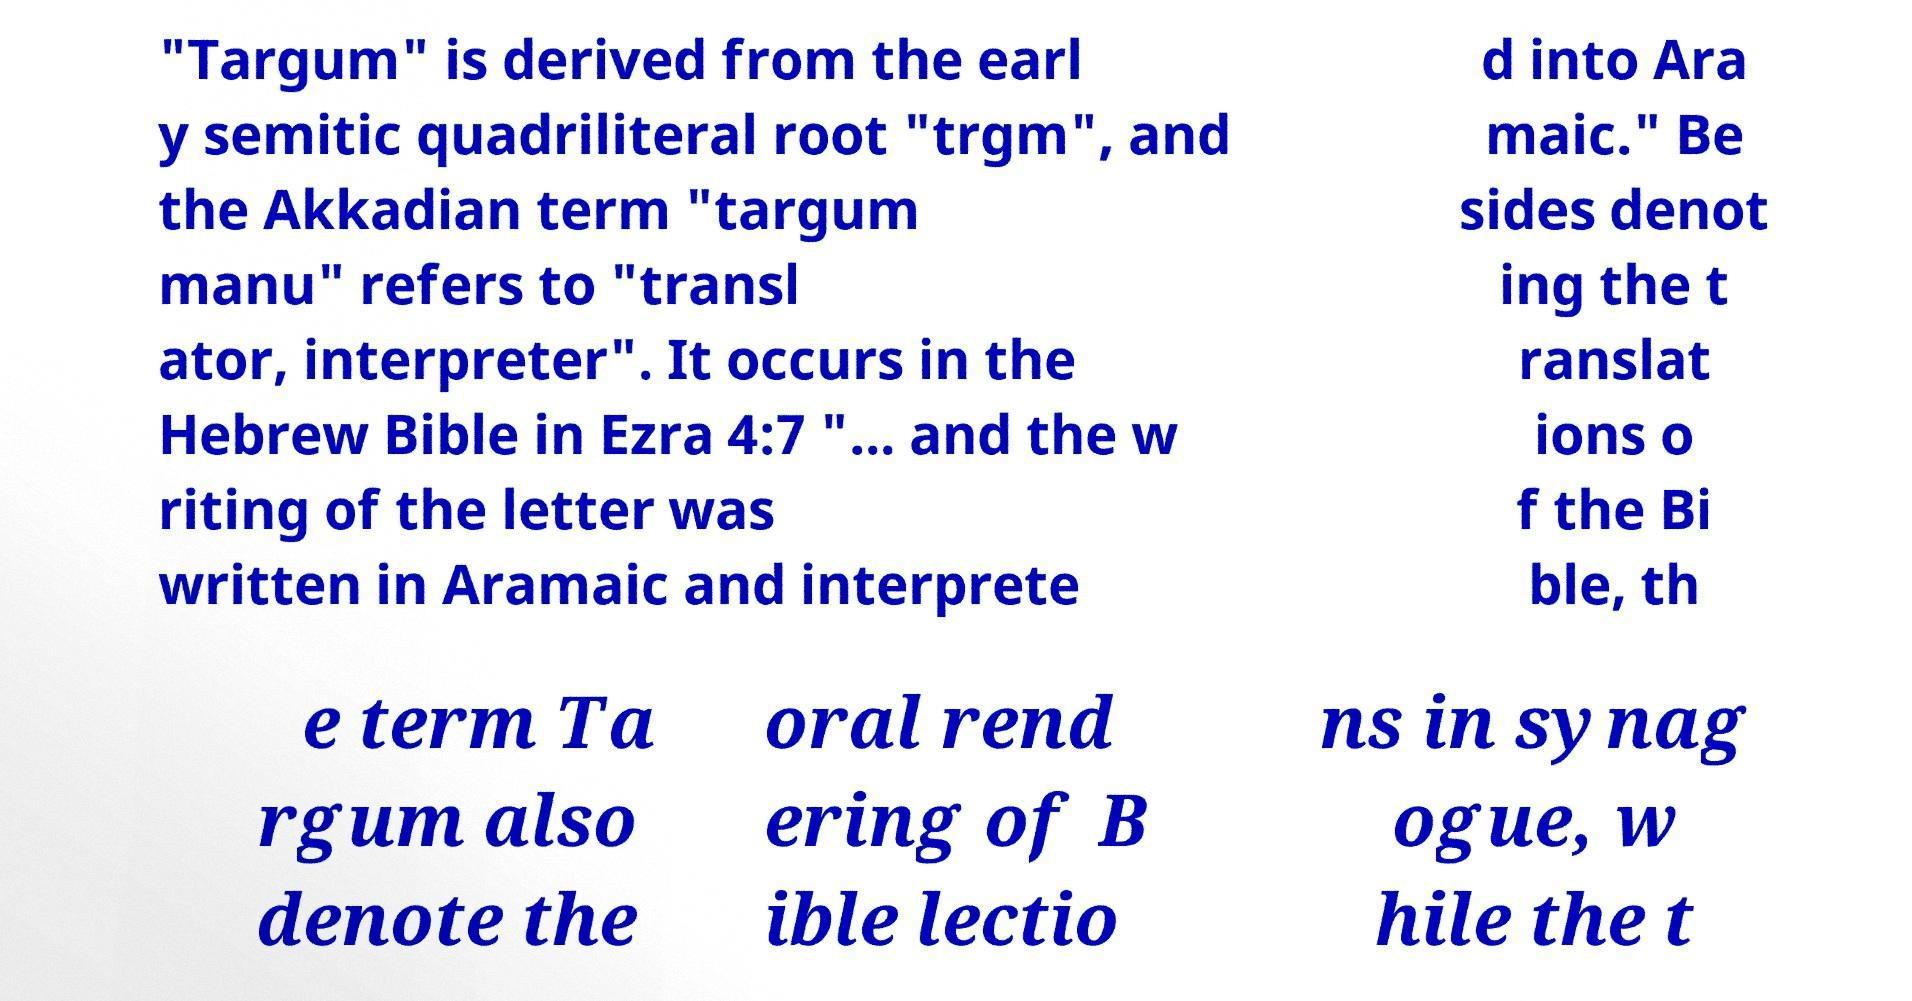Could you assist in decoding the text presented in this image and type it out clearly? "Targum" is derived from the earl y semitic quadriliteral root "trgm", and the Akkadian term "targum manu" refers to "transl ator, interpreter". It occurs in the Hebrew Bible in Ezra 4:7 "... and the w riting of the letter was written in Aramaic and interprete d into Ara maic." Be sides denot ing the t ranslat ions o f the Bi ble, th e term Ta rgum also denote the oral rend ering of B ible lectio ns in synag ogue, w hile the t 